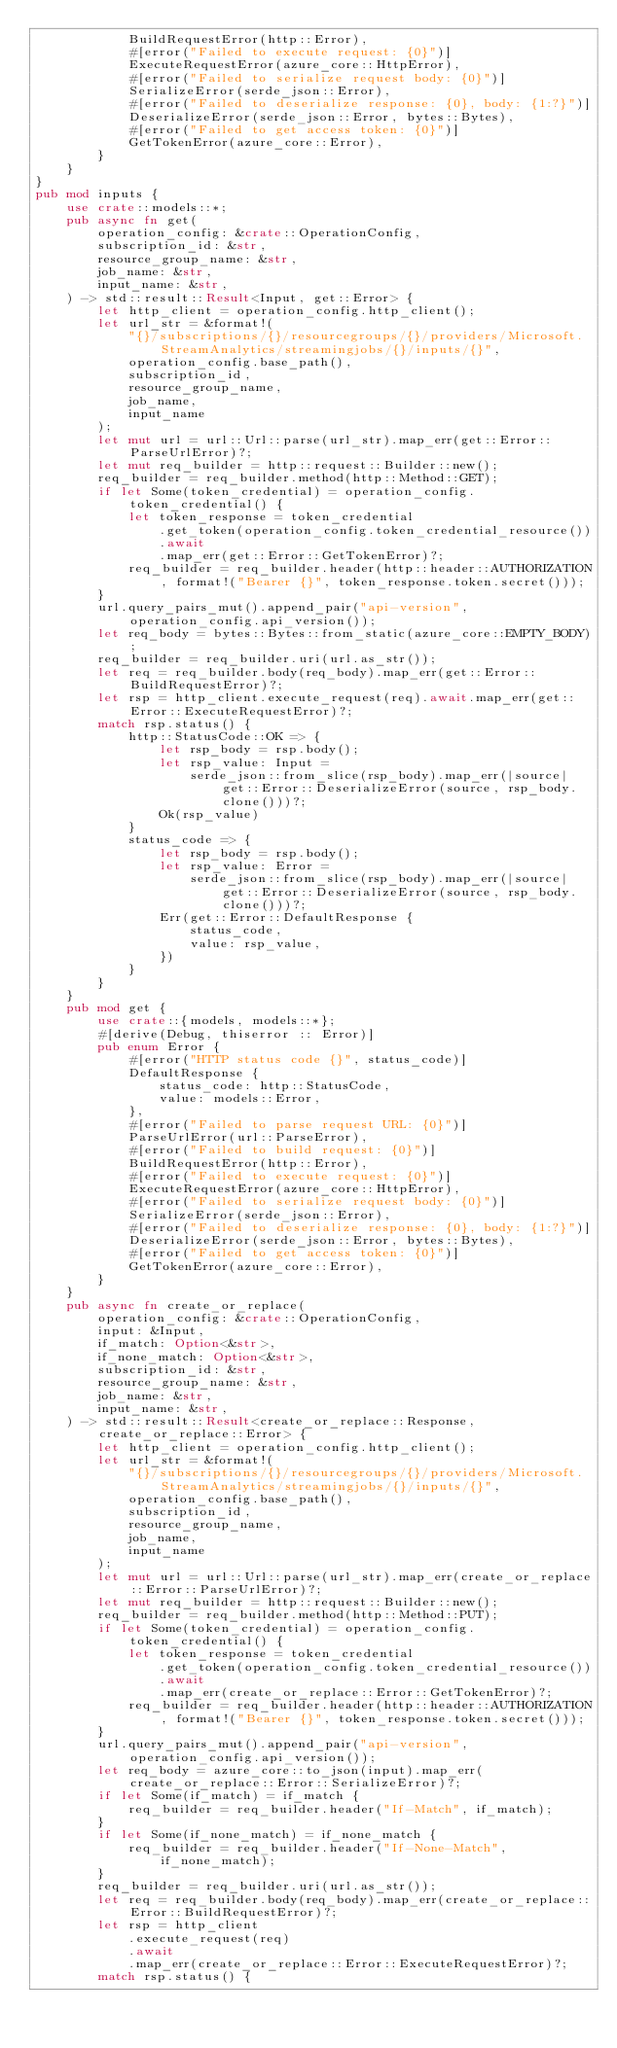<code> <loc_0><loc_0><loc_500><loc_500><_Rust_>            BuildRequestError(http::Error),
            #[error("Failed to execute request: {0}")]
            ExecuteRequestError(azure_core::HttpError),
            #[error("Failed to serialize request body: {0}")]
            SerializeError(serde_json::Error),
            #[error("Failed to deserialize response: {0}, body: {1:?}")]
            DeserializeError(serde_json::Error, bytes::Bytes),
            #[error("Failed to get access token: {0}")]
            GetTokenError(azure_core::Error),
        }
    }
}
pub mod inputs {
    use crate::models::*;
    pub async fn get(
        operation_config: &crate::OperationConfig,
        subscription_id: &str,
        resource_group_name: &str,
        job_name: &str,
        input_name: &str,
    ) -> std::result::Result<Input, get::Error> {
        let http_client = operation_config.http_client();
        let url_str = &format!(
            "{}/subscriptions/{}/resourcegroups/{}/providers/Microsoft.StreamAnalytics/streamingjobs/{}/inputs/{}",
            operation_config.base_path(),
            subscription_id,
            resource_group_name,
            job_name,
            input_name
        );
        let mut url = url::Url::parse(url_str).map_err(get::Error::ParseUrlError)?;
        let mut req_builder = http::request::Builder::new();
        req_builder = req_builder.method(http::Method::GET);
        if let Some(token_credential) = operation_config.token_credential() {
            let token_response = token_credential
                .get_token(operation_config.token_credential_resource())
                .await
                .map_err(get::Error::GetTokenError)?;
            req_builder = req_builder.header(http::header::AUTHORIZATION, format!("Bearer {}", token_response.token.secret()));
        }
        url.query_pairs_mut().append_pair("api-version", operation_config.api_version());
        let req_body = bytes::Bytes::from_static(azure_core::EMPTY_BODY);
        req_builder = req_builder.uri(url.as_str());
        let req = req_builder.body(req_body).map_err(get::Error::BuildRequestError)?;
        let rsp = http_client.execute_request(req).await.map_err(get::Error::ExecuteRequestError)?;
        match rsp.status() {
            http::StatusCode::OK => {
                let rsp_body = rsp.body();
                let rsp_value: Input =
                    serde_json::from_slice(rsp_body).map_err(|source| get::Error::DeserializeError(source, rsp_body.clone()))?;
                Ok(rsp_value)
            }
            status_code => {
                let rsp_body = rsp.body();
                let rsp_value: Error =
                    serde_json::from_slice(rsp_body).map_err(|source| get::Error::DeserializeError(source, rsp_body.clone()))?;
                Err(get::Error::DefaultResponse {
                    status_code,
                    value: rsp_value,
                })
            }
        }
    }
    pub mod get {
        use crate::{models, models::*};
        #[derive(Debug, thiserror :: Error)]
        pub enum Error {
            #[error("HTTP status code {}", status_code)]
            DefaultResponse {
                status_code: http::StatusCode,
                value: models::Error,
            },
            #[error("Failed to parse request URL: {0}")]
            ParseUrlError(url::ParseError),
            #[error("Failed to build request: {0}")]
            BuildRequestError(http::Error),
            #[error("Failed to execute request: {0}")]
            ExecuteRequestError(azure_core::HttpError),
            #[error("Failed to serialize request body: {0}")]
            SerializeError(serde_json::Error),
            #[error("Failed to deserialize response: {0}, body: {1:?}")]
            DeserializeError(serde_json::Error, bytes::Bytes),
            #[error("Failed to get access token: {0}")]
            GetTokenError(azure_core::Error),
        }
    }
    pub async fn create_or_replace(
        operation_config: &crate::OperationConfig,
        input: &Input,
        if_match: Option<&str>,
        if_none_match: Option<&str>,
        subscription_id: &str,
        resource_group_name: &str,
        job_name: &str,
        input_name: &str,
    ) -> std::result::Result<create_or_replace::Response, create_or_replace::Error> {
        let http_client = operation_config.http_client();
        let url_str = &format!(
            "{}/subscriptions/{}/resourcegroups/{}/providers/Microsoft.StreamAnalytics/streamingjobs/{}/inputs/{}",
            operation_config.base_path(),
            subscription_id,
            resource_group_name,
            job_name,
            input_name
        );
        let mut url = url::Url::parse(url_str).map_err(create_or_replace::Error::ParseUrlError)?;
        let mut req_builder = http::request::Builder::new();
        req_builder = req_builder.method(http::Method::PUT);
        if let Some(token_credential) = operation_config.token_credential() {
            let token_response = token_credential
                .get_token(operation_config.token_credential_resource())
                .await
                .map_err(create_or_replace::Error::GetTokenError)?;
            req_builder = req_builder.header(http::header::AUTHORIZATION, format!("Bearer {}", token_response.token.secret()));
        }
        url.query_pairs_mut().append_pair("api-version", operation_config.api_version());
        let req_body = azure_core::to_json(input).map_err(create_or_replace::Error::SerializeError)?;
        if let Some(if_match) = if_match {
            req_builder = req_builder.header("If-Match", if_match);
        }
        if let Some(if_none_match) = if_none_match {
            req_builder = req_builder.header("If-None-Match", if_none_match);
        }
        req_builder = req_builder.uri(url.as_str());
        let req = req_builder.body(req_body).map_err(create_or_replace::Error::BuildRequestError)?;
        let rsp = http_client
            .execute_request(req)
            .await
            .map_err(create_or_replace::Error::ExecuteRequestError)?;
        match rsp.status() {</code> 